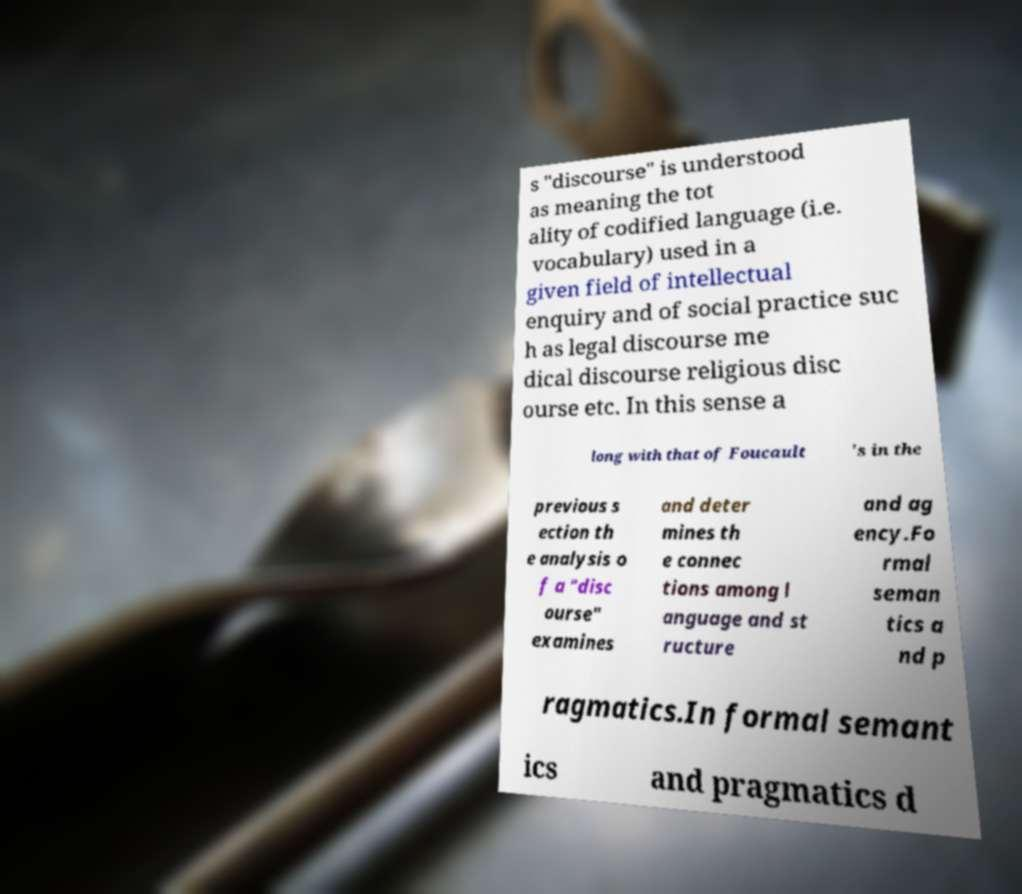For documentation purposes, I need the text within this image transcribed. Could you provide that? s "discourse" is understood as meaning the tot ality of codified language (i.e. vocabulary) used in a given field of intellectual enquiry and of social practice suc h as legal discourse me dical discourse religious disc ourse etc. In this sense a long with that of Foucault 's in the previous s ection th e analysis o f a "disc ourse" examines and deter mines th e connec tions among l anguage and st ructure and ag ency.Fo rmal seman tics a nd p ragmatics.In formal semant ics and pragmatics d 